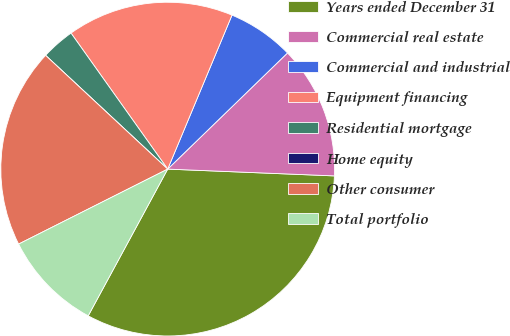Convert chart. <chart><loc_0><loc_0><loc_500><loc_500><pie_chart><fcel>Years ended December 31<fcel>Commercial real estate<fcel>Commercial and industrial<fcel>Equipment financing<fcel>Residential mortgage<fcel>Home equity<fcel>Other consumer<fcel>Total portfolio<nl><fcel>32.25%<fcel>12.9%<fcel>6.45%<fcel>16.13%<fcel>3.23%<fcel>0.0%<fcel>19.35%<fcel>9.68%<nl></chart> 